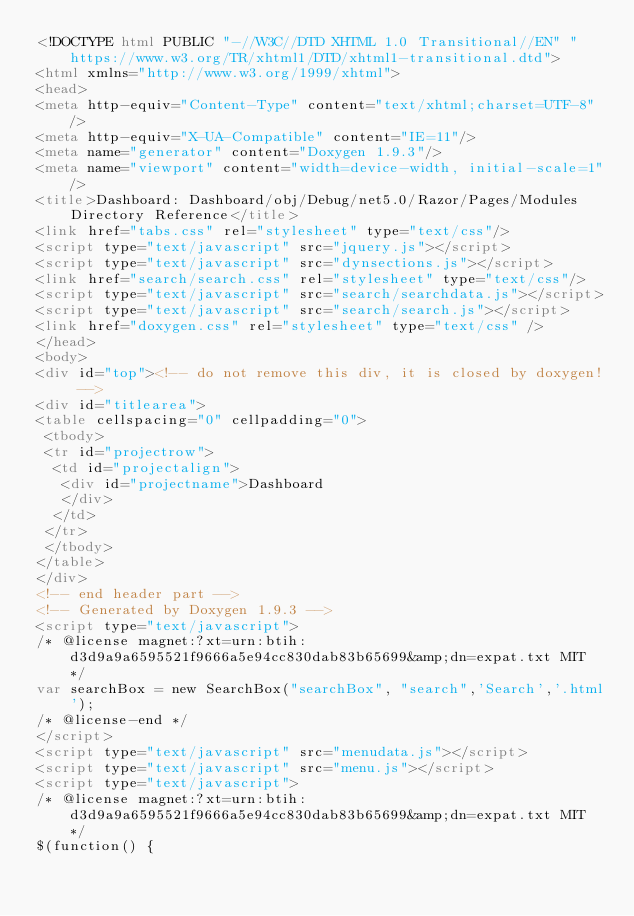<code> <loc_0><loc_0><loc_500><loc_500><_HTML_><!DOCTYPE html PUBLIC "-//W3C//DTD XHTML 1.0 Transitional//EN" "https://www.w3.org/TR/xhtml1/DTD/xhtml1-transitional.dtd">
<html xmlns="http://www.w3.org/1999/xhtml">
<head>
<meta http-equiv="Content-Type" content="text/xhtml;charset=UTF-8"/>
<meta http-equiv="X-UA-Compatible" content="IE=11"/>
<meta name="generator" content="Doxygen 1.9.3"/>
<meta name="viewport" content="width=device-width, initial-scale=1"/>
<title>Dashboard: Dashboard/obj/Debug/net5.0/Razor/Pages/Modules Directory Reference</title>
<link href="tabs.css" rel="stylesheet" type="text/css"/>
<script type="text/javascript" src="jquery.js"></script>
<script type="text/javascript" src="dynsections.js"></script>
<link href="search/search.css" rel="stylesheet" type="text/css"/>
<script type="text/javascript" src="search/searchdata.js"></script>
<script type="text/javascript" src="search/search.js"></script>
<link href="doxygen.css" rel="stylesheet" type="text/css" />
</head>
<body>
<div id="top"><!-- do not remove this div, it is closed by doxygen! -->
<div id="titlearea">
<table cellspacing="0" cellpadding="0">
 <tbody>
 <tr id="projectrow">
  <td id="projectalign">
   <div id="projectname">Dashboard
   </div>
  </td>
 </tr>
 </tbody>
</table>
</div>
<!-- end header part -->
<!-- Generated by Doxygen 1.9.3 -->
<script type="text/javascript">
/* @license magnet:?xt=urn:btih:d3d9a9a6595521f9666a5e94cc830dab83b65699&amp;dn=expat.txt MIT */
var searchBox = new SearchBox("searchBox", "search",'Search','.html');
/* @license-end */
</script>
<script type="text/javascript" src="menudata.js"></script>
<script type="text/javascript" src="menu.js"></script>
<script type="text/javascript">
/* @license magnet:?xt=urn:btih:d3d9a9a6595521f9666a5e94cc830dab83b65699&amp;dn=expat.txt MIT */
$(function() {</code> 